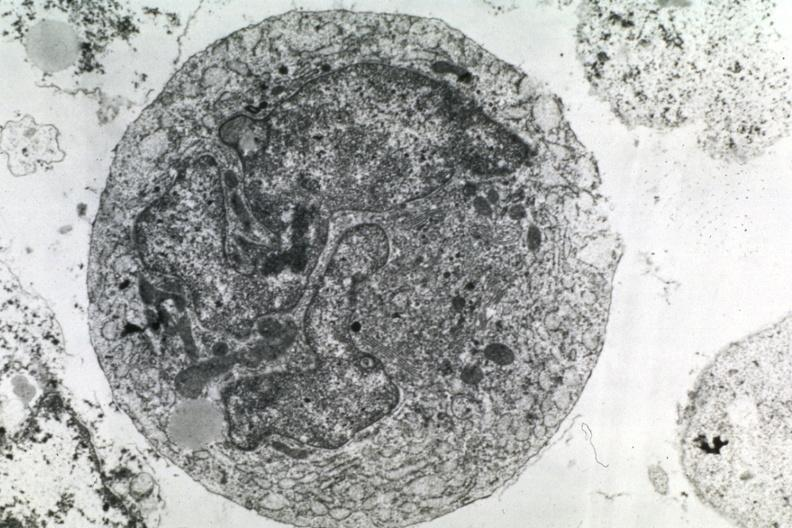what does this image show?
Answer the question using a single word or phrase. Dr garcia tumors 50 